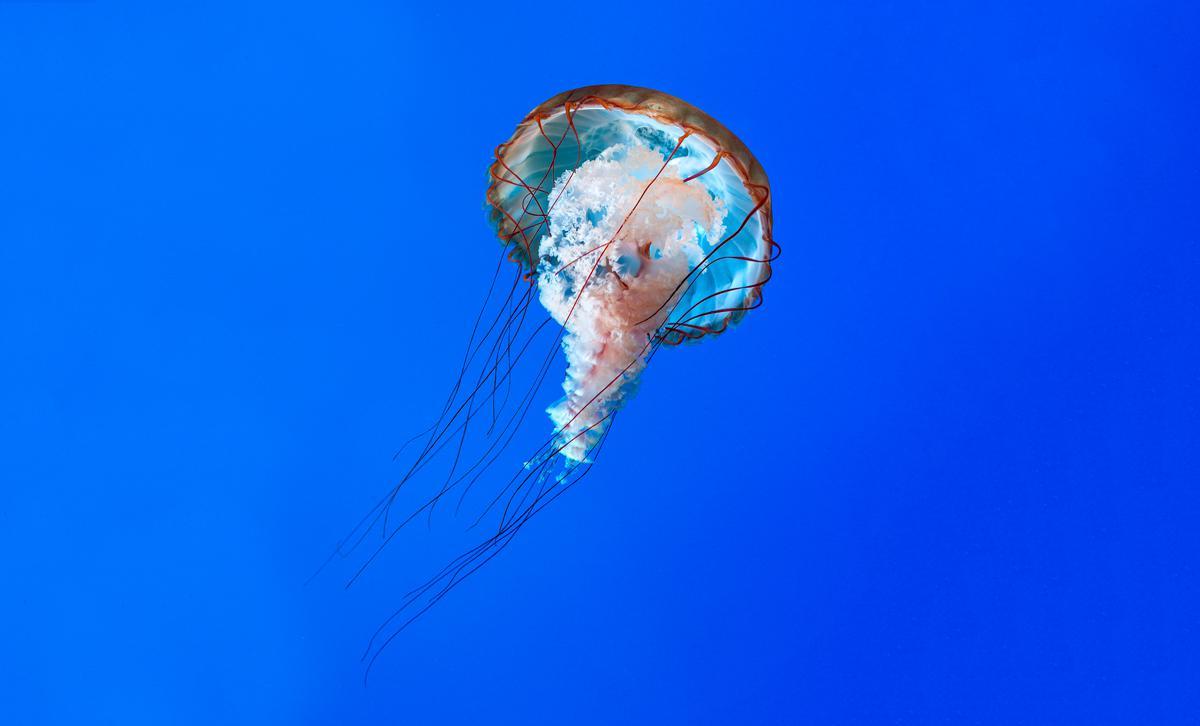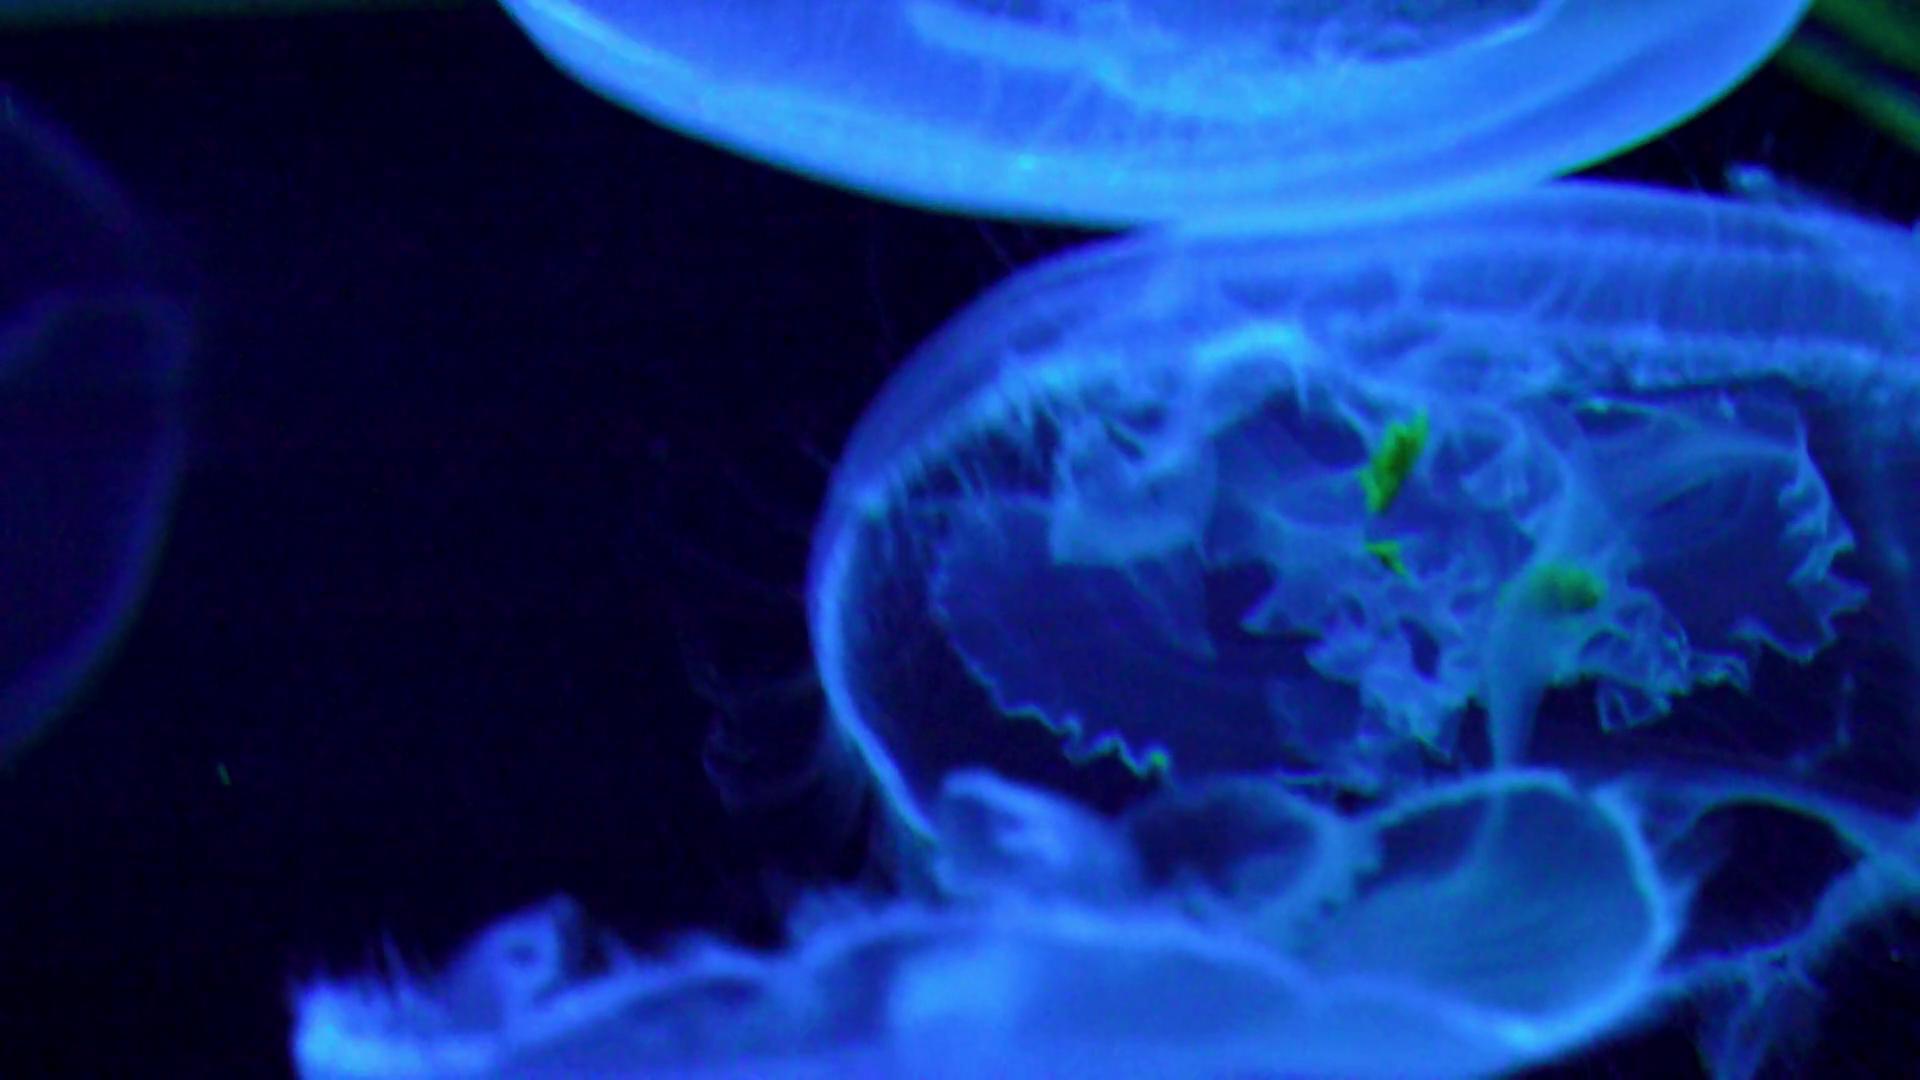The first image is the image on the left, the second image is the image on the right. Considering the images on both sides, is "In at least one image there is a circle jellyfish with its head looking like a four leaf clover." valid? Answer yes or no. No. The first image is the image on the left, the second image is the image on the right. Analyze the images presented: Is the assertion "In one image at least one jellyfish is upside down." valid? Answer yes or no. No. 